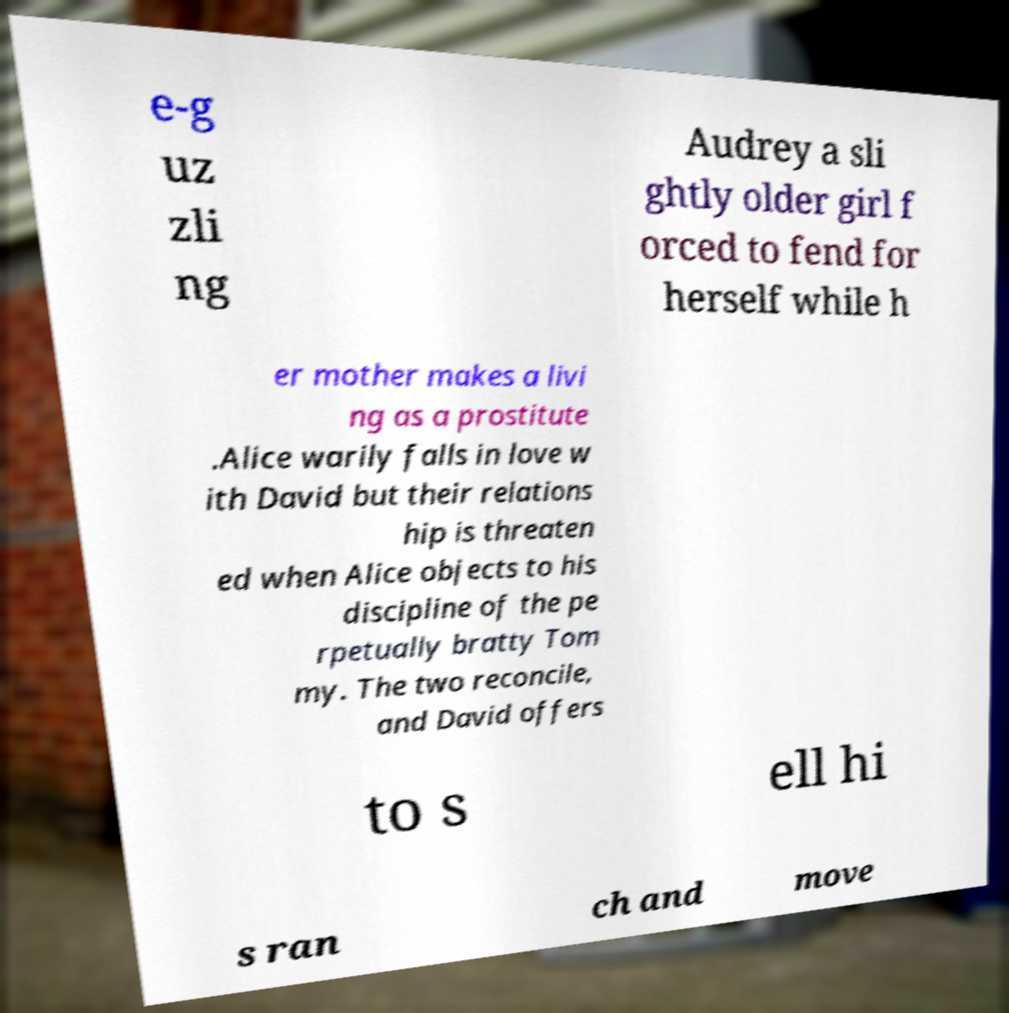Could you assist in decoding the text presented in this image and type it out clearly? e-g uz zli ng Audrey a sli ghtly older girl f orced to fend for herself while h er mother makes a livi ng as a prostitute .Alice warily falls in love w ith David but their relations hip is threaten ed when Alice objects to his discipline of the pe rpetually bratty Tom my. The two reconcile, and David offers to s ell hi s ran ch and move 